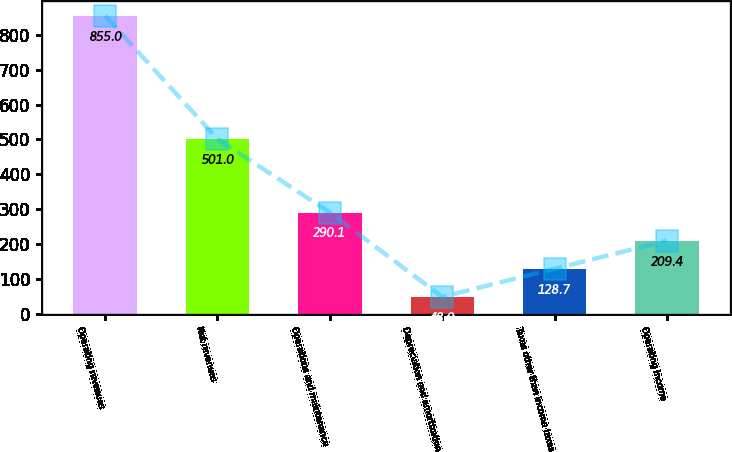<chart> <loc_0><loc_0><loc_500><loc_500><bar_chart><fcel>Operating revenues<fcel>Net revenues<fcel>Operations and maintenance<fcel>Depreciation and amortization<fcel>Taxes other than income taxes<fcel>Operating income<nl><fcel>855<fcel>501<fcel>290.1<fcel>48<fcel>128.7<fcel>209.4<nl></chart> 